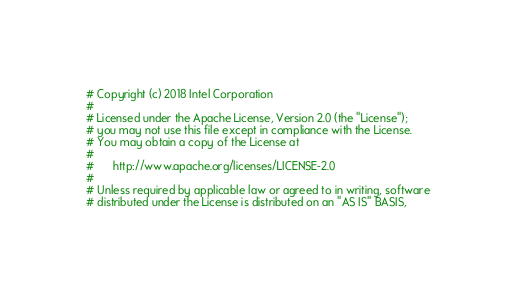<code> <loc_0><loc_0><loc_500><loc_500><_Python_># Copyright (c) 2018 Intel Corporation
#
# Licensed under the Apache License, Version 2.0 (the "License");
# you may not use this file except in compliance with the License.
# You may obtain a copy of the License at
#
#      http://www.apache.org/licenses/LICENSE-2.0
#
# Unless required by applicable law or agreed to in writing, software
# distributed under the License is distributed on an "AS IS" BASIS,</code> 